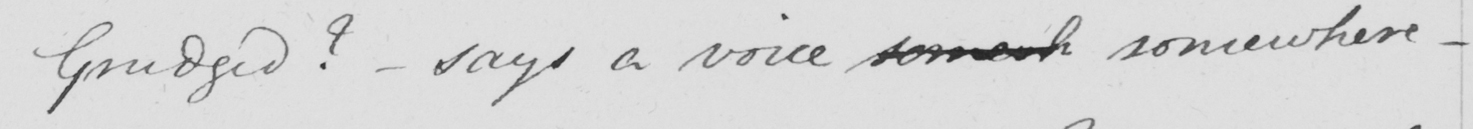Please provide the text content of this handwritten line. Grudged  ?   _  says a voice somewh somewhere  _ 